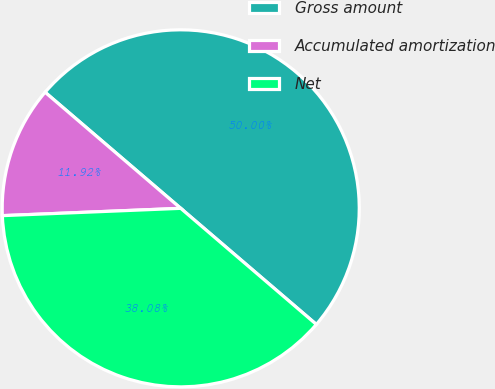Convert chart. <chart><loc_0><loc_0><loc_500><loc_500><pie_chart><fcel>Gross amount<fcel>Accumulated amortization<fcel>Net<nl><fcel>50.0%<fcel>11.92%<fcel>38.08%<nl></chart> 